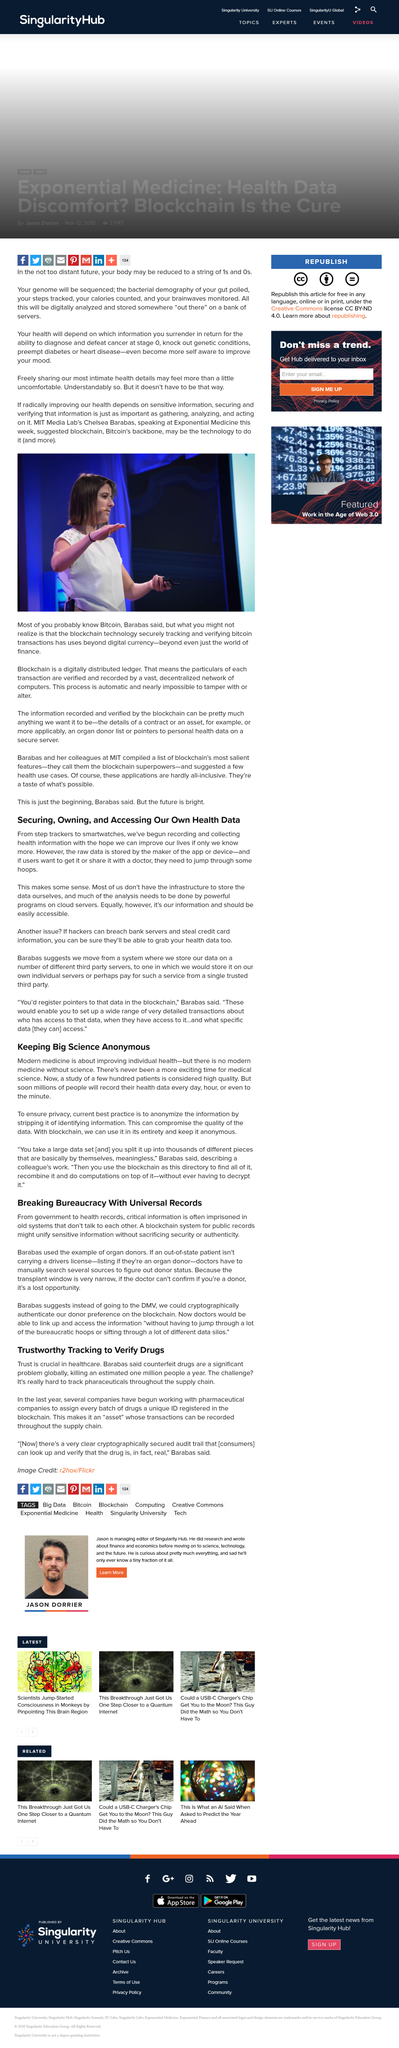Draw attention to some important aspects in this diagram. Yes, steps are a component of the most personal health information that will be freely disclosed. It is possible to keep big science anonymous by removing identifying information. The act of recording and collecting health information has been undertaken with the objective of enhancing our lives by enabling us to better understand and improve our health. Blockchain is the foundation, the backbone, of Bitcoin, providing the secure and transparent system that underpins the entire cryptocurrency. Chelsea Barabas is affiliated with the Massachusetts Institute of Technology (MIT) Media Labs. 